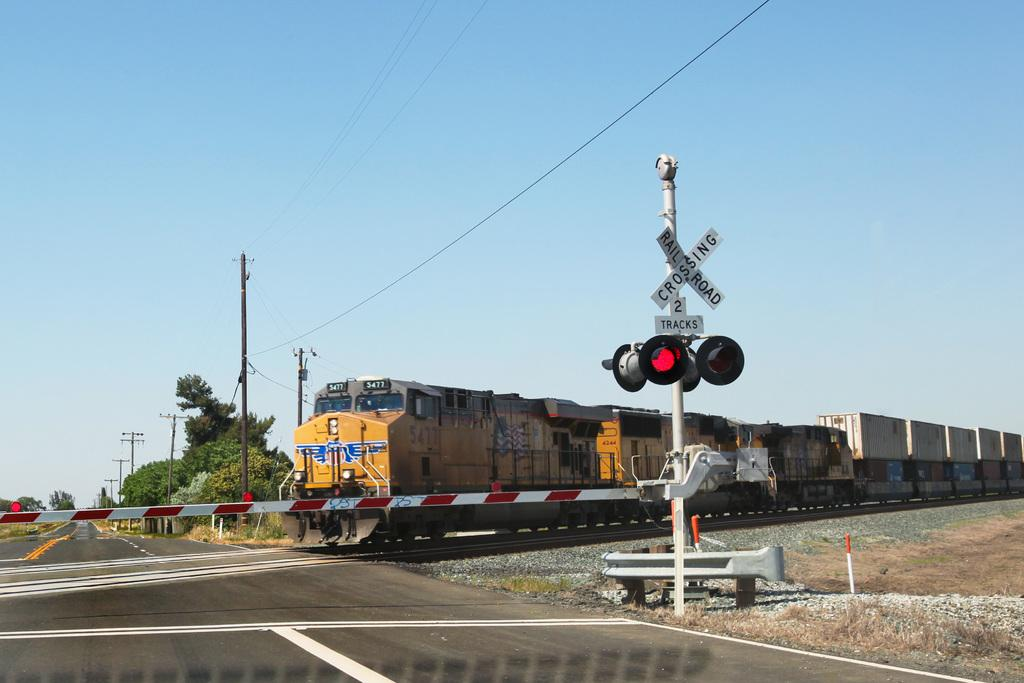<image>
Give a short and clear explanation of the subsequent image. A yellow train, 5477, at a road crossing, the sign read RAILDROAD CROSSING 2 TRACKS 